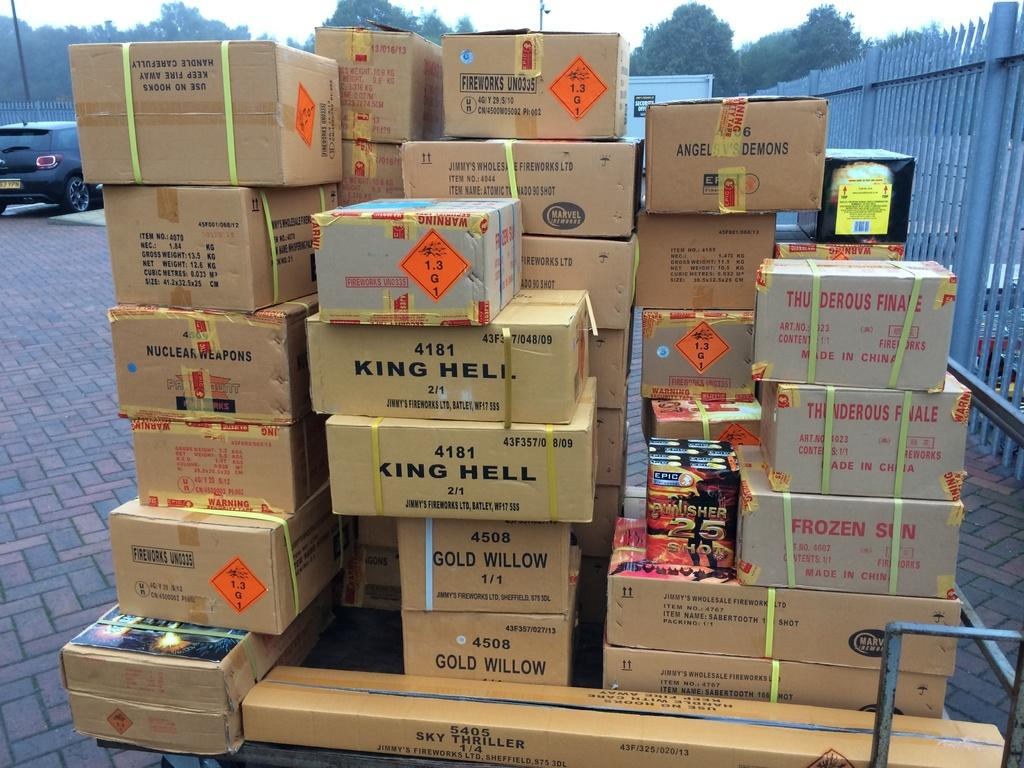<image>
Present a compact description of the photo's key features. A pallet of different types of fireworks including Sky Thriller and Thunderous Finale. 